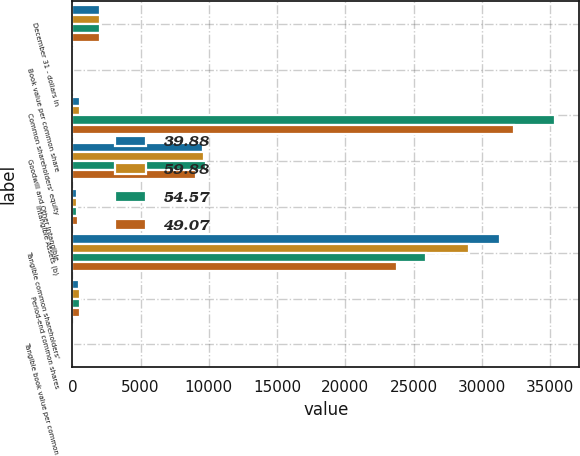Convert chart to OTSL. <chart><loc_0><loc_0><loc_500><loc_500><stacked_bar_chart><ecel><fcel>December 31 - dollars in<fcel>Book value per common share<fcel>Common shareholders' equity<fcel>Goodwill and Other Intangible<fcel>Intangible Assets (b)<fcel>Tangible common shareholders'<fcel>Period-end common shares<fcel>Tangible book value per common<nl><fcel>39.88<fcel>2014<fcel>77.61<fcel>530.5<fcel>9595<fcel>320<fcel>31330<fcel>523<fcel>59.88<nl><fcel>59.88<fcel>2013<fcel>72.07<fcel>530.5<fcel>9654<fcel>333<fcel>29071<fcel>533<fcel>54.57<nl><fcel>54.57<fcel>2012<fcel>66.95<fcel>35358<fcel>9798<fcel>354<fcel>25914<fcel>528<fcel>49.07<nl><fcel>49.07<fcel>2011<fcel>61.44<fcel>32374<fcel>9027<fcel>431<fcel>23778<fcel>527<fcel>45.13<nl></chart> 